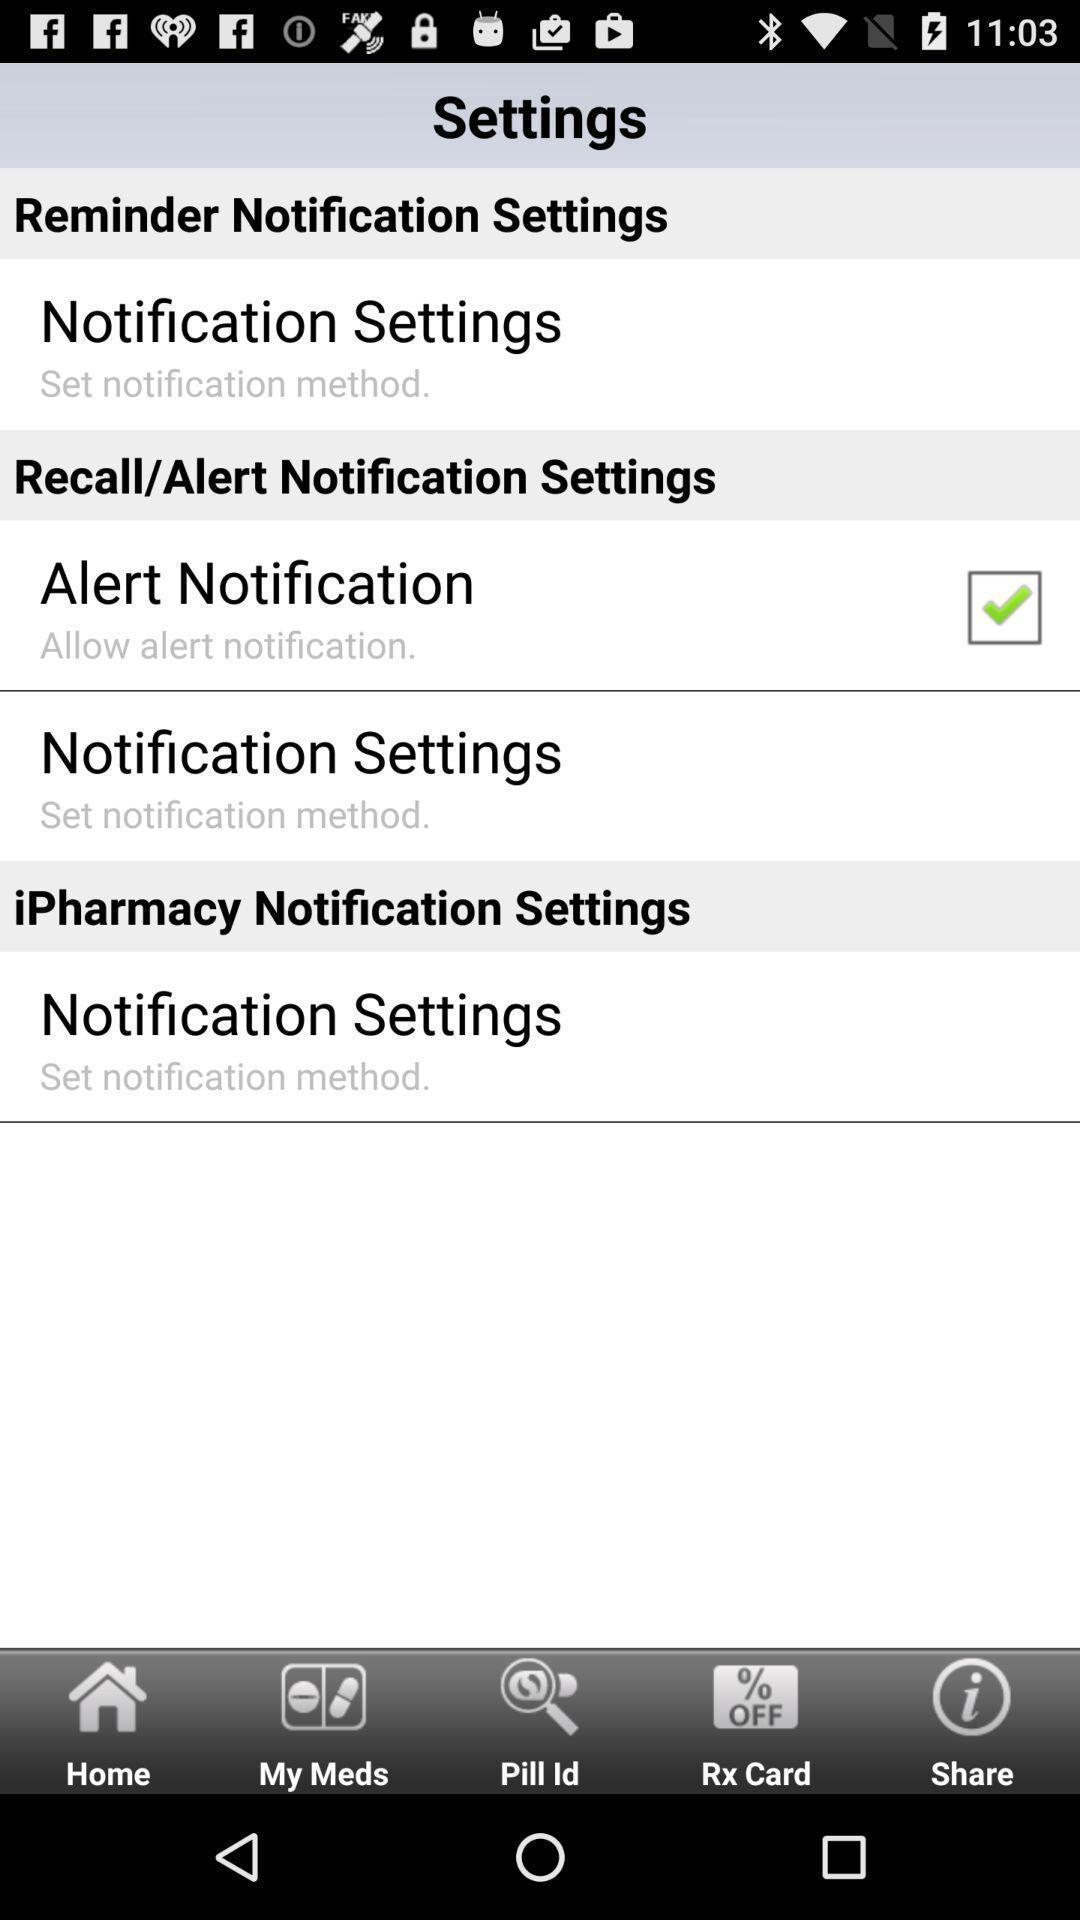Give me a summary of this screen capture. Settings page with number of options to enable. 